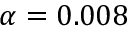Convert formula to latex. <formula><loc_0><loc_0><loc_500><loc_500>\alpha = 0 . 0 0 8</formula> 